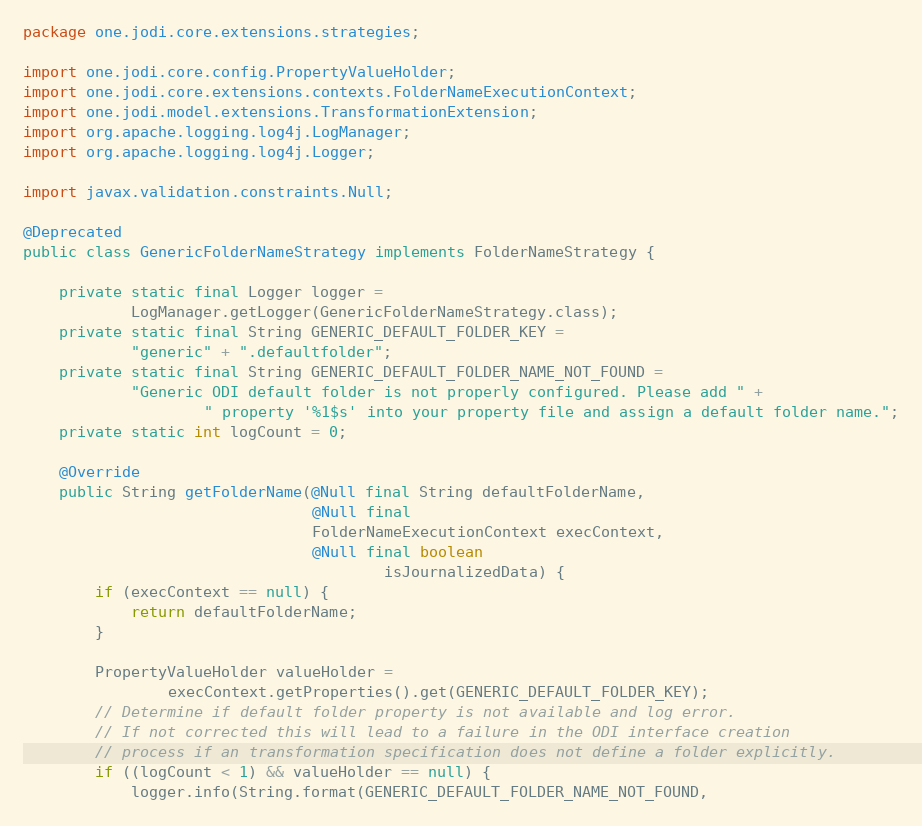<code> <loc_0><loc_0><loc_500><loc_500><_Java_>package one.jodi.core.extensions.strategies;

import one.jodi.core.config.PropertyValueHolder;
import one.jodi.core.extensions.contexts.FolderNameExecutionContext;
import one.jodi.model.extensions.TransformationExtension;
import org.apache.logging.log4j.LogManager;
import org.apache.logging.log4j.Logger;

import javax.validation.constraints.Null;

@Deprecated
public class GenericFolderNameStrategy implements FolderNameStrategy {

    private static final Logger logger =
            LogManager.getLogger(GenericFolderNameStrategy.class);
    private static final String GENERIC_DEFAULT_FOLDER_KEY =
            "generic" + ".defaultfolder";
    private static final String GENERIC_DEFAULT_FOLDER_NAME_NOT_FOUND =
            "Generic ODI default folder is not properly configured. Please add " +
                    " property '%1$s' into your property file and assign a default folder name.";
    private static int logCount = 0;

    @Override
    public String getFolderName(@Null final String defaultFolderName,
                                @Null final
                                FolderNameExecutionContext execContext,
                                @Null final boolean
                                        isJournalizedData) {
        if (execContext == null) {
            return defaultFolderName;
        }

        PropertyValueHolder valueHolder =
                execContext.getProperties().get(GENERIC_DEFAULT_FOLDER_KEY);
        // Determine if default folder property is not available and log error.
        // If not corrected this will lead to a failure in the ODI interface creation
        // process if an transformation specification does not define a folder explicitly.
        if ((logCount < 1) && valueHolder == null) {
            logger.info(String.format(GENERIC_DEFAULT_FOLDER_NAME_NOT_FOUND,</code> 